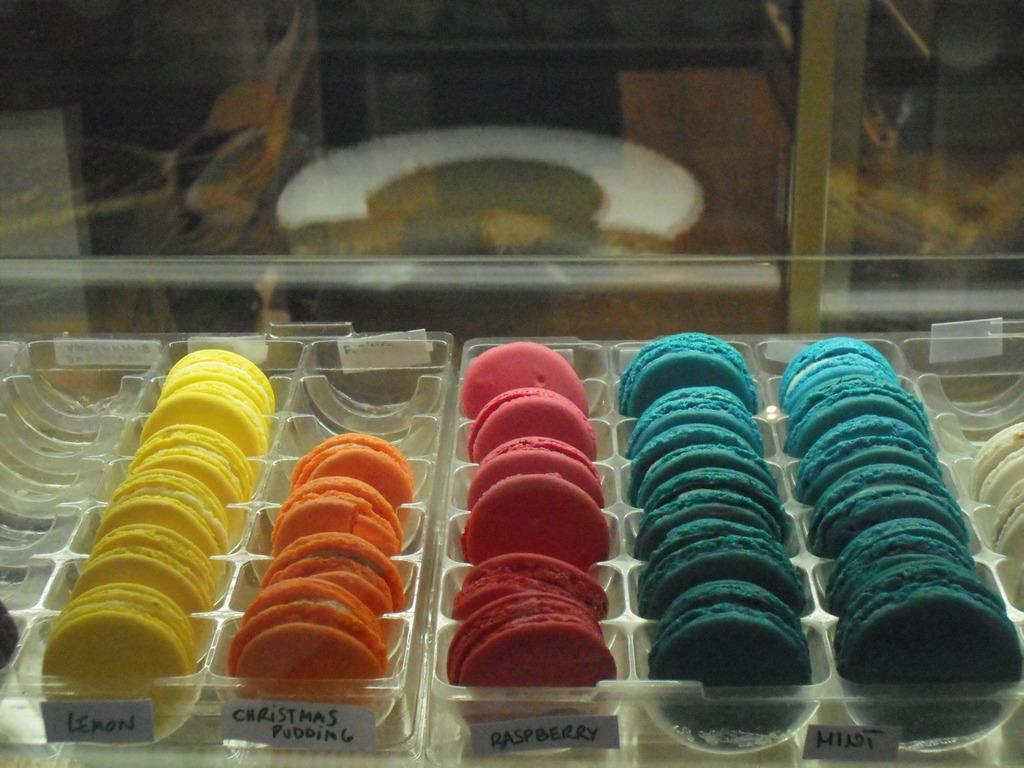<image>
Write a terse but informative summary of the picture. many cookies and a few that say christmas cookies on them 